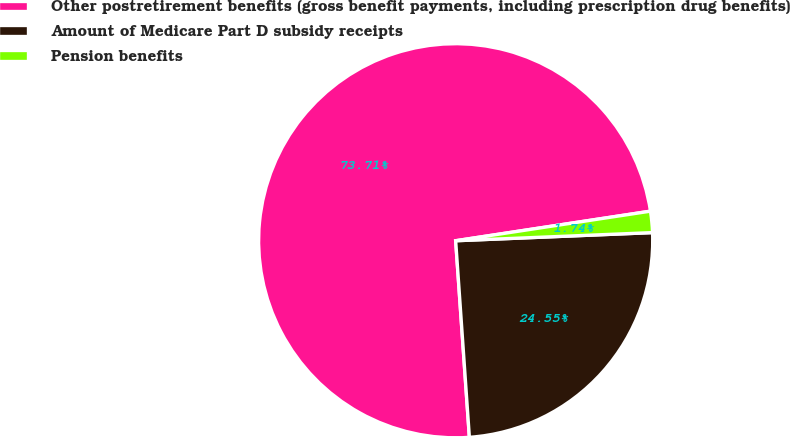Convert chart. <chart><loc_0><loc_0><loc_500><loc_500><pie_chart><fcel>Other postretirement benefits (gross benefit payments, including prescription drug benefits)<fcel>Amount of Medicare Part D subsidy receipts<fcel>Pension benefits<nl><fcel>73.71%<fcel>24.55%<fcel>1.74%<nl></chart> 